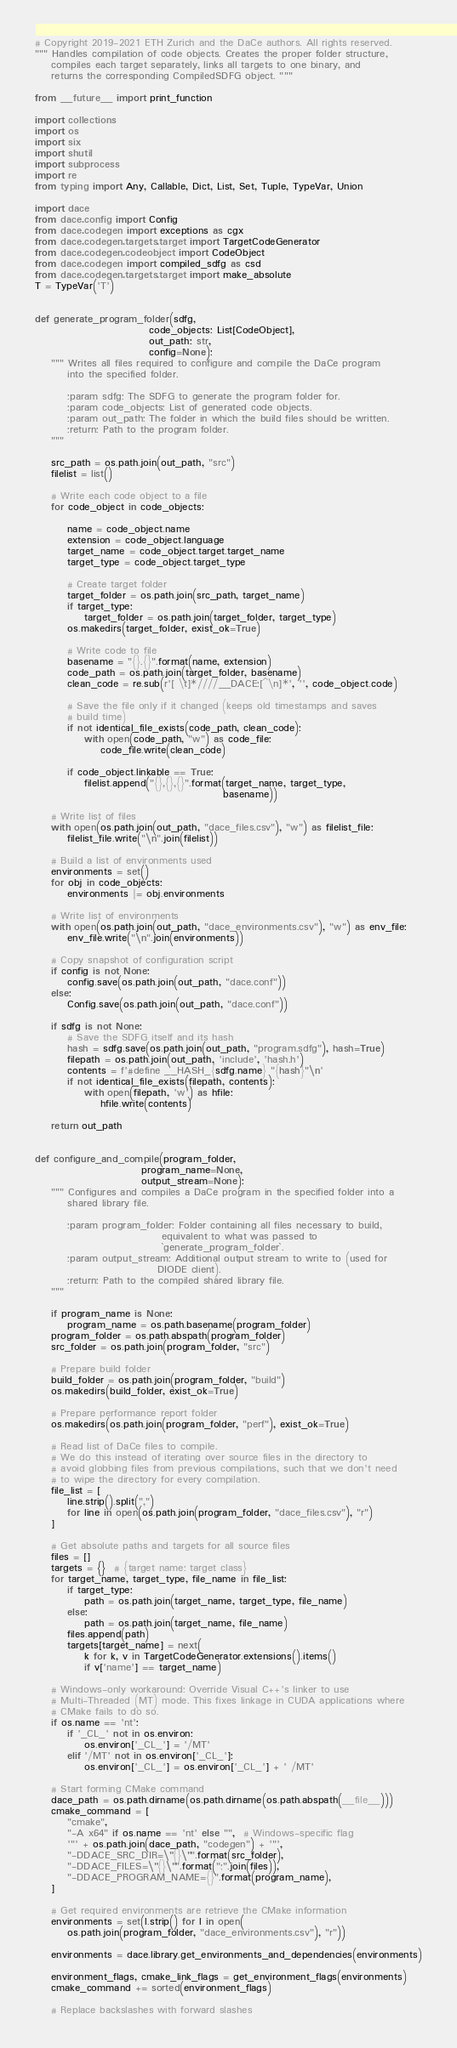<code> <loc_0><loc_0><loc_500><loc_500><_Python_># Copyright 2019-2021 ETH Zurich and the DaCe authors. All rights reserved.
""" Handles compilation of code objects. Creates the proper folder structure,
    compiles each target separately, links all targets to one binary, and
    returns the corresponding CompiledSDFG object. """

from __future__ import print_function

import collections
import os
import six
import shutil
import subprocess
import re
from typing import Any, Callable, Dict, List, Set, Tuple, TypeVar, Union

import dace
from dace.config import Config
from dace.codegen import exceptions as cgx
from dace.codegen.targets.target import TargetCodeGenerator
from dace.codegen.codeobject import CodeObject
from dace.codegen import compiled_sdfg as csd
from dace.codegen.targets.target import make_absolute
T = TypeVar('T')


def generate_program_folder(sdfg,
                            code_objects: List[CodeObject],
                            out_path: str,
                            config=None):
    """ Writes all files required to configure and compile the DaCe program
        into the specified folder.

        :param sdfg: The SDFG to generate the program folder for.
        :param code_objects: List of generated code objects.
        :param out_path: The folder in which the build files should be written.
        :return: Path to the program folder.
    """

    src_path = os.path.join(out_path, "src")
    filelist = list()

    # Write each code object to a file
    for code_object in code_objects:

        name = code_object.name
        extension = code_object.language
        target_name = code_object.target.target_name
        target_type = code_object.target_type

        # Create target folder
        target_folder = os.path.join(src_path, target_name)
        if target_type:
            target_folder = os.path.join(target_folder, target_type)
        os.makedirs(target_folder, exist_ok=True)

        # Write code to file
        basename = "{}.{}".format(name, extension)
        code_path = os.path.join(target_folder, basename)
        clean_code = re.sub(r'[ \t]*////__DACE:[^\n]*', '', code_object.code)

        # Save the file only if it changed (keeps old timestamps and saves
        # build time)
        if not identical_file_exists(code_path, clean_code):
            with open(code_path, "w") as code_file:
                code_file.write(clean_code)

        if code_object.linkable == True:
            filelist.append("{},{},{}".format(target_name, target_type,
                                              basename))

    # Write list of files
    with open(os.path.join(out_path, "dace_files.csv"), "w") as filelist_file:
        filelist_file.write("\n".join(filelist))

    # Build a list of environments used
    environments = set()
    for obj in code_objects:
        environments |= obj.environments

    # Write list of environments
    with open(os.path.join(out_path, "dace_environments.csv"), "w") as env_file:
        env_file.write("\n".join(environments))

    # Copy snapshot of configuration script
    if config is not None:
        config.save(os.path.join(out_path, "dace.conf"))
    else:
        Config.save(os.path.join(out_path, "dace.conf"))

    if sdfg is not None:
        # Save the SDFG itself and its hash
        hash = sdfg.save(os.path.join(out_path, "program.sdfg"), hash=True)
        filepath = os.path.join(out_path, 'include', 'hash.h') 
        contents = f'#define __HASH_{sdfg.name} "{hash}"\n'
        if not identical_file_exists(filepath, contents):
            with open(filepath, 'w') as hfile:
                hfile.write(contents)

    return out_path


def configure_and_compile(program_folder,
                          program_name=None,
                          output_stream=None):
    """ Configures and compiles a DaCe program in the specified folder into a
        shared library file.

        :param program_folder: Folder containing all files necessary to build,
                               equivalent to what was passed to
                               `generate_program_folder`.
        :param output_stream: Additional output stream to write to (used for
                              DIODE client).
        :return: Path to the compiled shared library file.
    """

    if program_name is None:
        program_name = os.path.basename(program_folder)
    program_folder = os.path.abspath(program_folder)
    src_folder = os.path.join(program_folder, "src")

    # Prepare build folder
    build_folder = os.path.join(program_folder, "build")
    os.makedirs(build_folder, exist_ok=True)

    # Prepare performance report folder
    os.makedirs(os.path.join(program_folder, "perf"), exist_ok=True)

    # Read list of DaCe files to compile.
    # We do this instead of iterating over source files in the directory to
    # avoid globbing files from previous compilations, such that we don't need
    # to wipe the directory for every compilation.
    file_list = [
        line.strip().split(",")
        for line in open(os.path.join(program_folder, "dace_files.csv"), "r")
    ]

    # Get absolute paths and targets for all source files
    files = []
    targets = {}  # {target name: target class}
    for target_name, target_type, file_name in file_list:
        if target_type:
            path = os.path.join(target_name, target_type, file_name)
        else:
            path = os.path.join(target_name, file_name)
        files.append(path)
        targets[target_name] = next(
            k for k, v in TargetCodeGenerator.extensions().items()
            if v['name'] == target_name)

    # Windows-only workaround: Override Visual C++'s linker to use
    # Multi-Threaded (MT) mode. This fixes linkage in CUDA applications where
    # CMake fails to do so.
    if os.name == 'nt':
        if '_CL_' not in os.environ:
            os.environ['_CL_'] = '/MT'
        elif '/MT' not in os.environ['_CL_']:
            os.environ['_CL_'] = os.environ['_CL_'] + ' /MT'

    # Start forming CMake command
    dace_path = os.path.dirname(os.path.dirname(os.path.abspath(__file__)))
    cmake_command = [
        "cmake",
        "-A x64" if os.name == 'nt' else "",  # Windows-specific flag
        '"' + os.path.join(dace_path, "codegen") + '"',
        "-DDACE_SRC_DIR=\"{}\"".format(src_folder),
        "-DDACE_FILES=\"{}\"".format(";".join(files)),
        "-DDACE_PROGRAM_NAME={}".format(program_name),
    ]

    # Get required environments are retrieve the CMake information
    environments = set(l.strip() for l in open(
        os.path.join(program_folder, "dace_environments.csv"), "r"))

    environments = dace.library.get_environments_and_dependencies(environments)

    environment_flags, cmake_link_flags = get_environment_flags(environments)
    cmake_command += sorted(environment_flags)

    # Replace backslashes with forward slashes</code> 